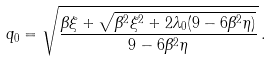<formula> <loc_0><loc_0><loc_500><loc_500>q _ { 0 } = \sqrt { \frac { \beta \xi + \sqrt { \beta ^ { 2 } \xi ^ { 2 } + 2 \lambda _ { 0 } ( 9 - 6 \beta ^ { 2 } \eta ) } } { 9 - 6 \beta ^ { 2 } \eta } } \, .</formula> 